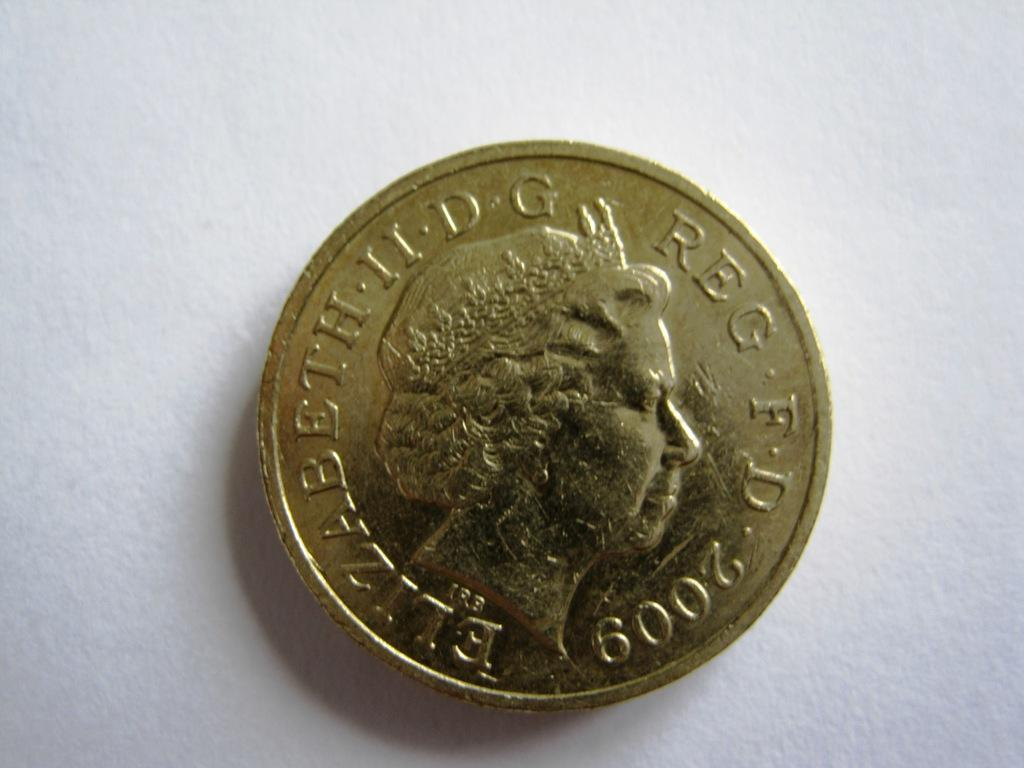<image>
Offer a succinct explanation of the picture presented. gold 2009 coin with queen elizabeth on it laying on white background 